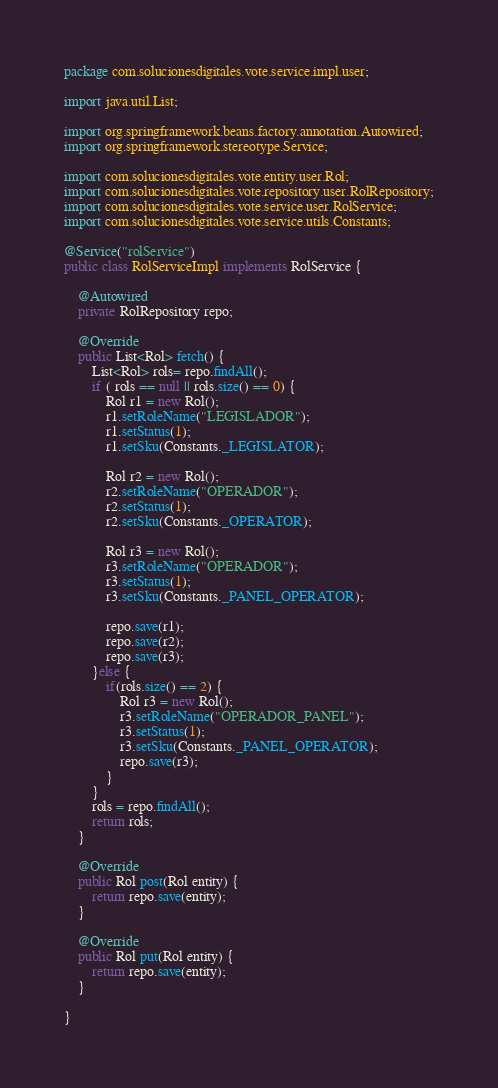<code> <loc_0><loc_0><loc_500><loc_500><_Java_>package com.solucionesdigitales.vote.service.impl.user;

import java.util.List;

import org.springframework.beans.factory.annotation.Autowired;
import org.springframework.stereotype.Service;

import com.solucionesdigitales.vote.entity.user.Rol;
import com.solucionesdigitales.vote.repository.user.RolRepository;
import com.solucionesdigitales.vote.service.user.RolService;
import com.solucionesdigitales.vote.service.utils.Constants;

@Service("rolService")
public class RolServiceImpl implements RolService {
	
	@Autowired
	private RolRepository repo;
	
	@Override
	public List<Rol> fetch() {
		List<Rol> rols= repo.findAll();
		if ( rols == null || rols.size() == 0) {
			Rol r1 = new Rol();
			r1.setRoleName("LEGISLADOR");
			r1.setStatus(1);
			r1.setSku(Constants._LEGISLATOR);
			
			Rol r2 = new Rol();
			r2.setRoleName("OPERADOR");
			r2.setStatus(1);
			r2.setSku(Constants._OPERATOR);
			
			Rol r3 = new Rol();
			r3.setRoleName("OPERADOR");
			r3.setStatus(1);
			r3.setSku(Constants._PANEL_OPERATOR);
			
			repo.save(r1);
			repo.save(r2);
			repo.save(r3);			
		}else {
			if(rols.size() == 2) {
				Rol r3 = new Rol();
				r3.setRoleName("OPERADOR_PANEL");
				r3.setStatus(1);
				r3.setSku(Constants._PANEL_OPERATOR);				
				repo.save(r3);
			}
		}
		rols = repo.findAll();
		return rols;
	}
	
	@Override
	public Rol post(Rol entity) {	
		return repo.save(entity);
	}

	@Override
	public Rol put(Rol entity) {	
		return repo.save(entity);
	}	

}
</code> 